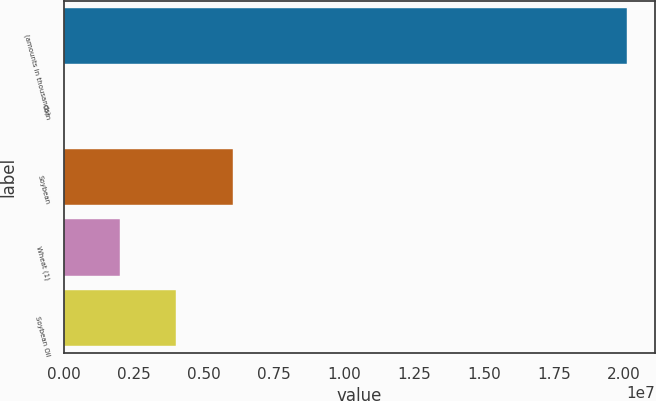Convert chart. <chart><loc_0><loc_0><loc_500><loc_500><bar_chart><fcel>(amounts in thousands)<fcel>Corn<fcel>Soybean<fcel>Wheat (1)<fcel>Soybean Oil<nl><fcel>2.0122e+07<fcel>8<fcel>6.03661e+06<fcel>2.01221e+06<fcel>4.02441e+06<nl></chart> 